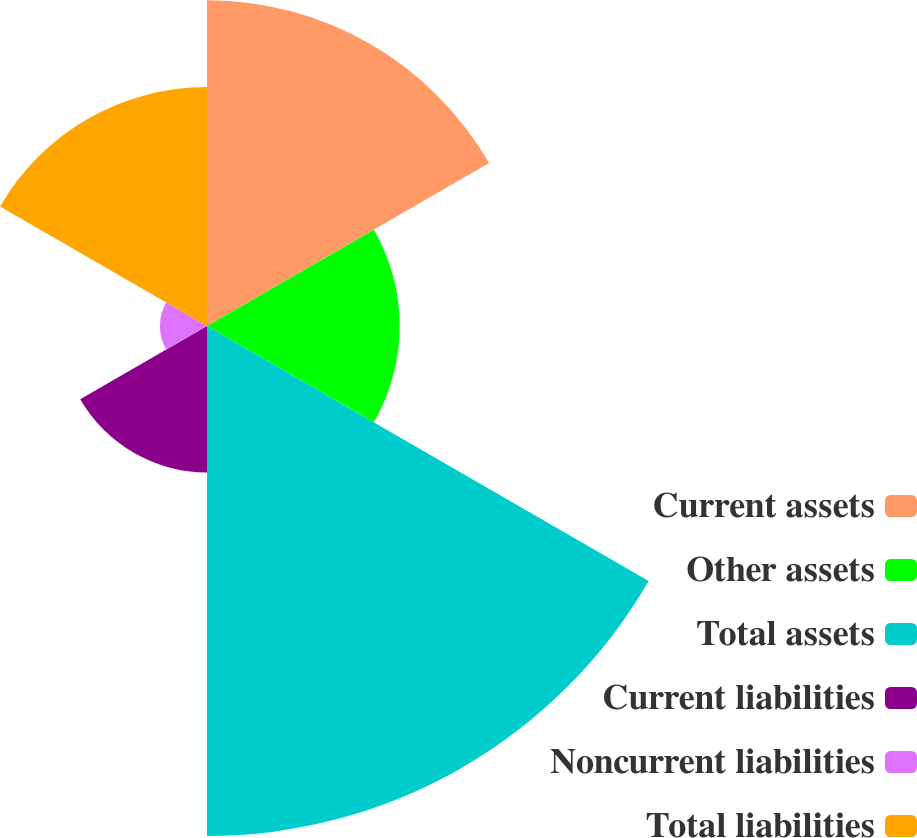Convert chart. <chart><loc_0><loc_0><loc_500><loc_500><pie_chart><fcel>Current assets<fcel>Other assets<fcel>Total assets<fcel>Current liabilities<fcel>Noncurrent liabilities<fcel>Total liabilities<nl><fcel>22.3%<fcel>13.19%<fcel>34.91%<fcel>10.02%<fcel>3.22%<fcel>16.36%<nl></chart> 